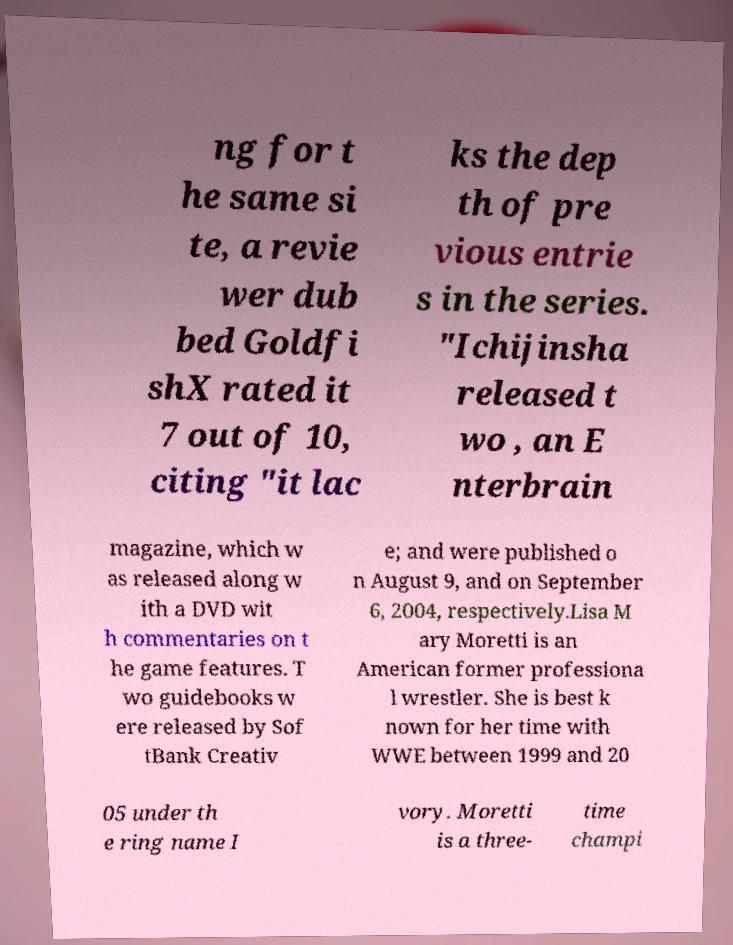Can you read and provide the text displayed in the image?This photo seems to have some interesting text. Can you extract and type it out for me? ng for t he same si te, a revie wer dub bed Goldfi shX rated it 7 out of 10, citing "it lac ks the dep th of pre vious entrie s in the series. "Ichijinsha released t wo , an E nterbrain magazine, which w as released along w ith a DVD wit h commentaries on t he game features. T wo guidebooks w ere released by Sof tBank Creativ e; and were published o n August 9, and on September 6, 2004, respectively.Lisa M ary Moretti is an American former professiona l wrestler. She is best k nown for her time with WWE between 1999 and 20 05 under th e ring name I vory. Moretti is a three- time champi 